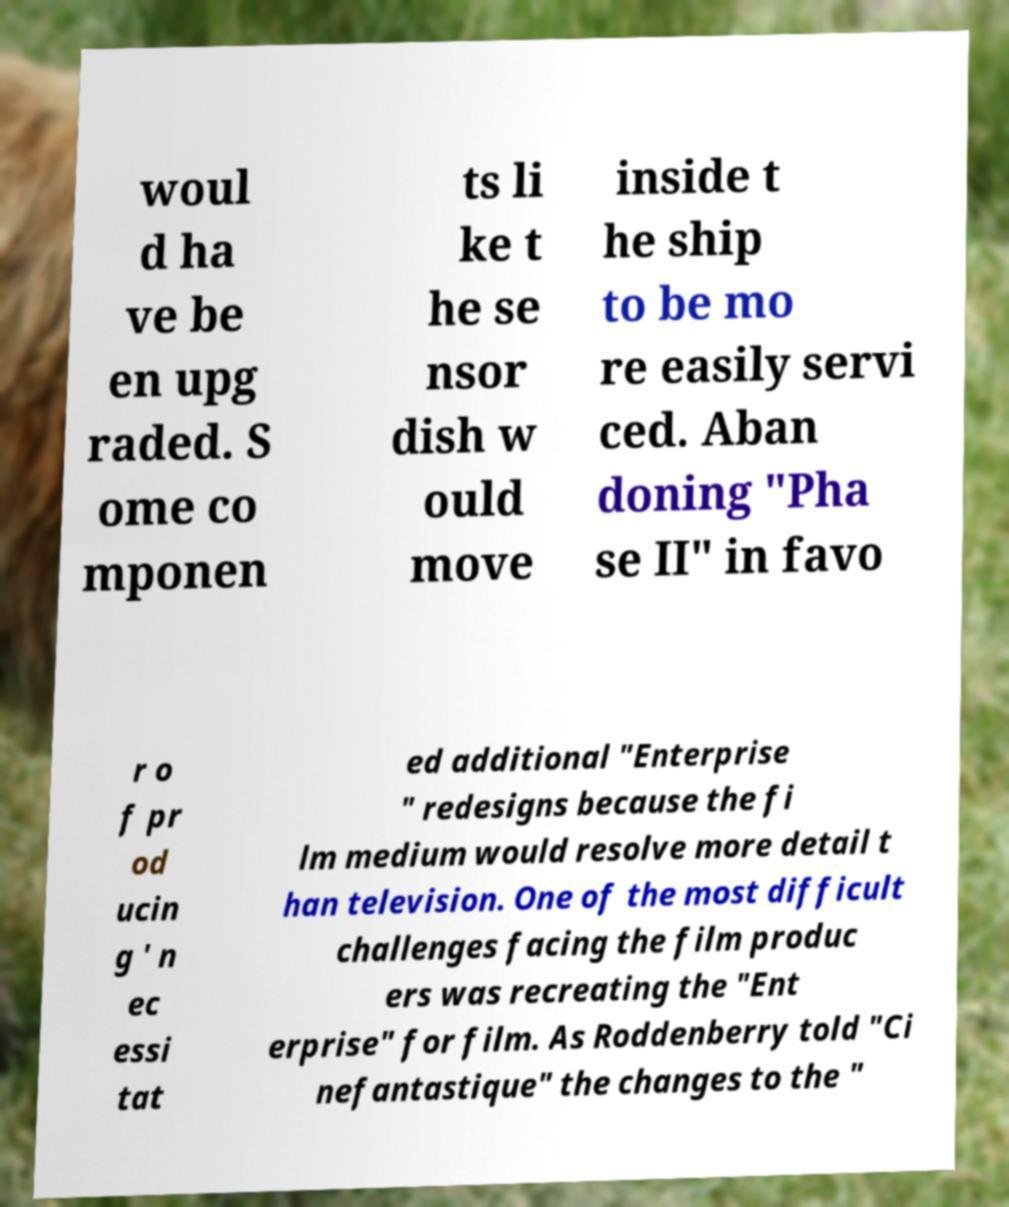Could you assist in decoding the text presented in this image and type it out clearly? woul d ha ve be en upg raded. S ome co mponen ts li ke t he se nsor dish w ould move inside t he ship to be mo re easily servi ced. Aban doning "Pha se II" in favo r o f pr od ucin g ' n ec essi tat ed additional "Enterprise " redesigns because the fi lm medium would resolve more detail t han television. One of the most difficult challenges facing the film produc ers was recreating the "Ent erprise" for film. As Roddenberry told "Ci nefantastique" the changes to the " 